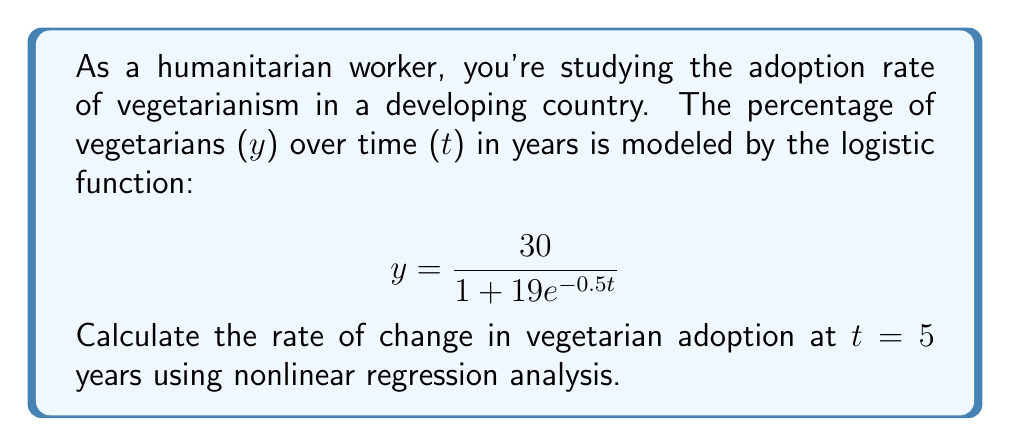Provide a solution to this math problem. To find the rate of change at t = 5, we need to calculate the derivative of the logistic function and evaluate it at t = 5.

Step 1: Calculate the derivative of the logistic function.
$$ \frac{dy}{dt} = \frac{30 \cdot 19 \cdot 0.5e^{-0.5t}}{(1 + 19e^{-0.5t})^2} $$

Step 2: Simplify the derivative.
$$ \frac{dy}{dt} = \frac{285e^{-0.5t}}{(1 + 19e^{-0.5t})^2} $$

Step 3: Evaluate the derivative at t = 5.
$$ \frac{dy}{dt}\bigg|_{t=5} = \frac{285e^{-0.5(5)}}{(1 + 19e^{-0.5(5)})^2} $$

Step 4: Calculate the exponential term.
$$ e^{-0.5(5)} = e^{-2.5} \approx 0.0821 $$

Step 5: Substitute this value into the equation.
$$ \frac{dy}{dt}\bigg|_{t=5} = \frac{285(0.0821)}{(1 + 19(0.0821))^2} $$

Step 6: Calculate the final result.
$$ \frac{dy}{dt}\bigg|_{t=5} \approx 2.37 $$

This means the rate of change in vegetarian adoption at t = 5 years is approximately 2.37% per year.
Answer: 2.37% per year 